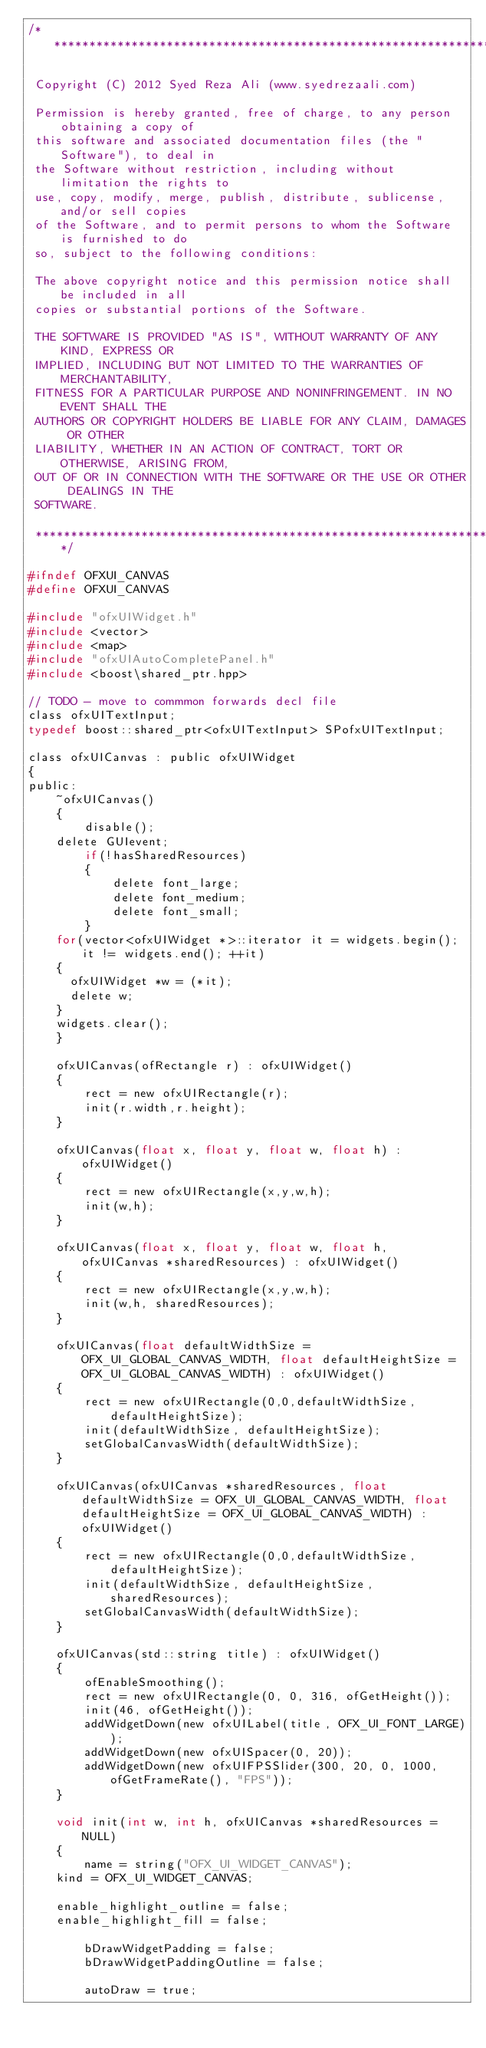Convert code to text. <code><loc_0><loc_0><loc_500><loc_500><_C_>/********************************************************************************** 
 
 Copyright (C) 2012 Syed Reza Ali (www.syedrezaali.com)
 
 Permission is hereby granted, free of charge, to any person obtaining a copy of
 this software and associated documentation files (the "Software"), to deal in
 the Software without restriction, including without limitation the rights to
 use, copy, modify, merge, publish, distribute, sublicense, and/or sell copies
 of the Software, and to permit persons to whom the Software is furnished to do
 so, subject to the following conditions:
 
 The above copyright notice and this permission notice shall be included in all
 copies or substantial portions of the Software.
 
 THE SOFTWARE IS PROVIDED "AS IS", WITHOUT WARRANTY OF ANY KIND, EXPRESS OR
 IMPLIED, INCLUDING BUT NOT LIMITED TO THE WARRANTIES OF MERCHANTABILITY,
 FITNESS FOR A PARTICULAR PURPOSE AND NONINFRINGEMENT. IN NO EVENT SHALL THE
 AUTHORS OR COPYRIGHT HOLDERS BE LIABLE FOR ANY CLAIM, DAMAGES OR OTHER
 LIABILITY, WHETHER IN AN ACTION OF CONTRACT, TORT OR OTHERWISE, ARISING FROM,
 OUT OF OR IN CONNECTION WITH THE SOFTWARE OR THE USE OR OTHER DEALINGS IN THE
 SOFTWARE.
 
 **********************************************************************************/

#ifndef OFXUI_CANVAS
#define OFXUI_CANVAS

#include "ofxUIWidget.h"
#include <vector>
#include <map>
#include "ofxUIAutoCompletePanel.h"
#include <boost\shared_ptr.hpp>

// TODO - move to commmon forwards decl file 
class ofxUITextInput;
typedef boost::shared_ptr<ofxUITextInput> SPofxUITextInput;

class ofxUICanvas : public ofxUIWidget
{    
public:
    ~ofxUICanvas() 
    {
        disable();
		delete GUIevent; 
        if(!hasSharedResources)
        {
            delete font_large; 
            delete font_medium;
            delete font_small;		
        }
		for(vector<ofxUIWidget *>::iterator it = widgets.begin(); it != widgets.end(); ++it)
		{
			ofxUIWidget *w = (*it);
			delete w;
		}
		widgets.clear();             
    }

    ofxUICanvas(ofRectangle r) : ofxUIWidget()
    {
        rect = new ofxUIRectangle(r);
        init(r.width,r.height);
    }
    
    ofxUICanvas(float x, float y, float w, float h) : ofxUIWidget() 
    {
        rect = new ofxUIRectangle(x,y,w,h);        
        init(w,h);
    }

    ofxUICanvas(float x, float y, float w, float h, ofxUICanvas *sharedResources) : ofxUIWidget() 
    {
        rect = new ofxUIRectangle(x,y,w,h);        
        init(w,h, sharedResources);
    }
    
    ofxUICanvas(float defaultWidthSize = OFX_UI_GLOBAL_CANVAS_WIDTH, float defaultHeightSize = OFX_UI_GLOBAL_CANVAS_WIDTH) : ofxUIWidget()
    {        
        rect = new ofxUIRectangle(0,0,defaultWidthSize,defaultHeightSize);
        init(defaultWidthSize, defaultHeightSize);
        setGlobalCanvasWidth(defaultWidthSize);
    }
    
    ofxUICanvas(ofxUICanvas *sharedResources, float defaultWidthSize = OFX_UI_GLOBAL_CANVAS_WIDTH, float defaultHeightSize = OFX_UI_GLOBAL_CANVAS_WIDTH) : ofxUIWidget()
    {
        rect = new ofxUIRectangle(0,0,defaultWidthSize,defaultHeightSize);
        init(defaultWidthSize, defaultHeightSize, sharedResources);
        setGlobalCanvasWidth(defaultWidthSize);
    }
    
    ofxUICanvas(std::string title) : ofxUIWidget()
    {
        ofEnableSmoothing();
        rect = new ofxUIRectangle(0, 0, 316, ofGetHeight());        
        init(46, ofGetHeight());
        addWidgetDown(new ofxUILabel(title, OFX_UI_FONT_LARGE));
        addWidgetDown(new ofxUISpacer(0, 20));
        addWidgetDown(new ofxUIFPSSlider(300, 20, 0, 1000, ofGetFrameRate(), "FPS"));
    }
    
    void init(int w, int h, ofxUICanvas *sharedResources = NULL)
    {        
        name = string("OFX_UI_WIDGET_CANVAS");
		kind = OFX_UI_WIDGET_CANVAS; 
		
		enable_highlight_outline = false; 
		enable_highlight_fill = false;     
        
        bDrawWidgetPadding = false;
        bDrawWidgetPaddingOutline = false;
        
        autoDraw = true;</code> 